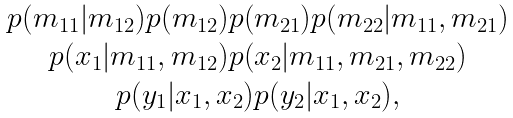<formula> <loc_0><loc_0><loc_500><loc_500>\begin{array} { c } p ( m _ { 1 1 } | m _ { 1 2 } ) p ( m _ { 1 2 } ) p ( m _ { 2 1 } ) p ( m _ { 2 2 } | m _ { 1 1 } , m _ { 2 1 } ) \\ p ( x _ { 1 } | m _ { 1 1 } , m _ { 1 2 } ) p ( x _ { 2 } | m _ { 1 1 } , m _ { 2 1 } , m _ { 2 2 } ) \\ p ( y _ { 1 } | x _ { 1 } , x _ { 2 } ) p ( y _ { 2 } | x _ { 1 } , x _ { 2 } ) , \end{array}</formula> 